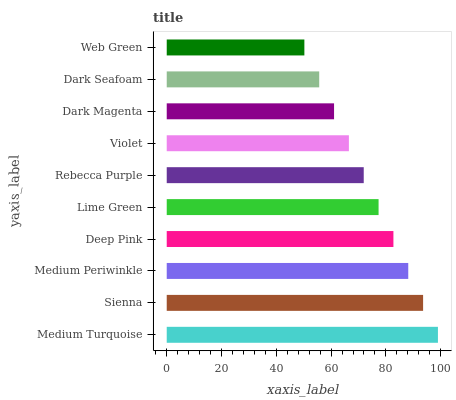Is Web Green the minimum?
Answer yes or no. Yes. Is Medium Turquoise the maximum?
Answer yes or no. Yes. Is Sienna the minimum?
Answer yes or no. No. Is Sienna the maximum?
Answer yes or no. No. Is Medium Turquoise greater than Sienna?
Answer yes or no. Yes. Is Sienna less than Medium Turquoise?
Answer yes or no. Yes. Is Sienna greater than Medium Turquoise?
Answer yes or no. No. Is Medium Turquoise less than Sienna?
Answer yes or no. No. Is Lime Green the high median?
Answer yes or no. Yes. Is Rebecca Purple the low median?
Answer yes or no. Yes. Is Violet the high median?
Answer yes or no. No. Is Sienna the low median?
Answer yes or no. No. 